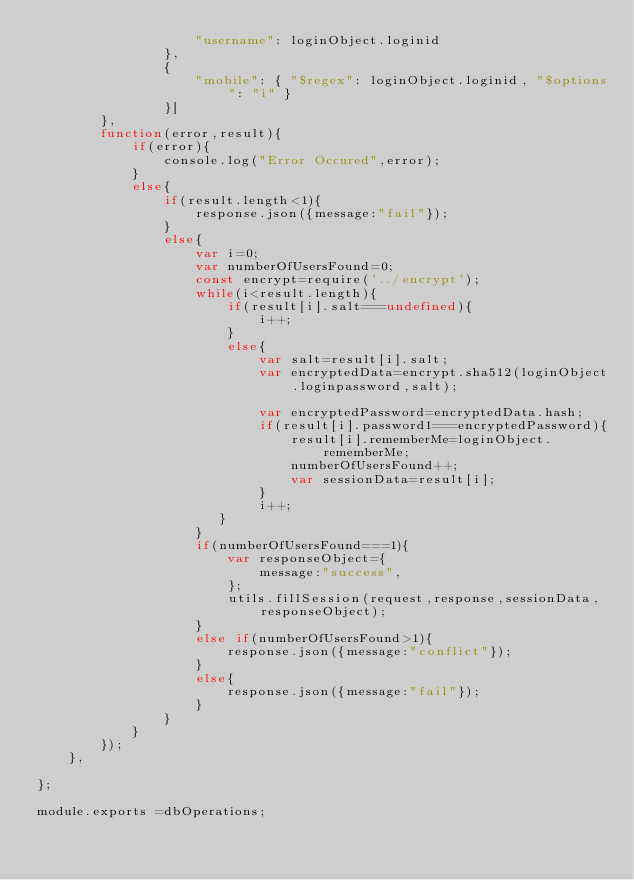Convert code to text. <code><loc_0><loc_0><loc_500><loc_500><_JavaScript_>                    "username": loginObject.loginid
                },
                {
                    "mobile": { "$regex": loginObject.loginid, "$options": "i" }
                }]
        },
        function(error,result){
            if(error){
                console.log("Error Occured",error);
            }
            else{ 
                if(result.length<1){
                    response.json({message:"fail"});
                }
                else{
                    var i=0;
                    var numberOfUsersFound=0;
                    const encrypt=require('../encrypt');
                    while(i<result.length){
                        if(result[i].salt===undefined){
                            i++;
                        }
                        else{
                            var salt=result[i].salt;
                            var encryptedData=encrypt.sha512(loginObject.loginpassword,salt);

                            var encryptedPassword=encryptedData.hash;
                            if(result[i].password1===encryptedPassword){
                                result[i].rememberMe=loginObject.rememberMe;
                                numberOfUsersFound++;
                                var sessionData=result[i];
                            }
                            i++;    
                       }
                    }
                    if(numberOfUsersFound===1){
                        var responseObject={
                            message:"success",
                        };
                        utils.fillSession(request,response,sessionData,responseObject);
                    }
                    else if(numberOfUsersFound>1){
                        response.json({message:"conflict"});
                    }
                    else{
                        response.json({message:"fail"});
                    }  
                }  
            }
        });
    },

};

module.exports =dbOperations;</code> 